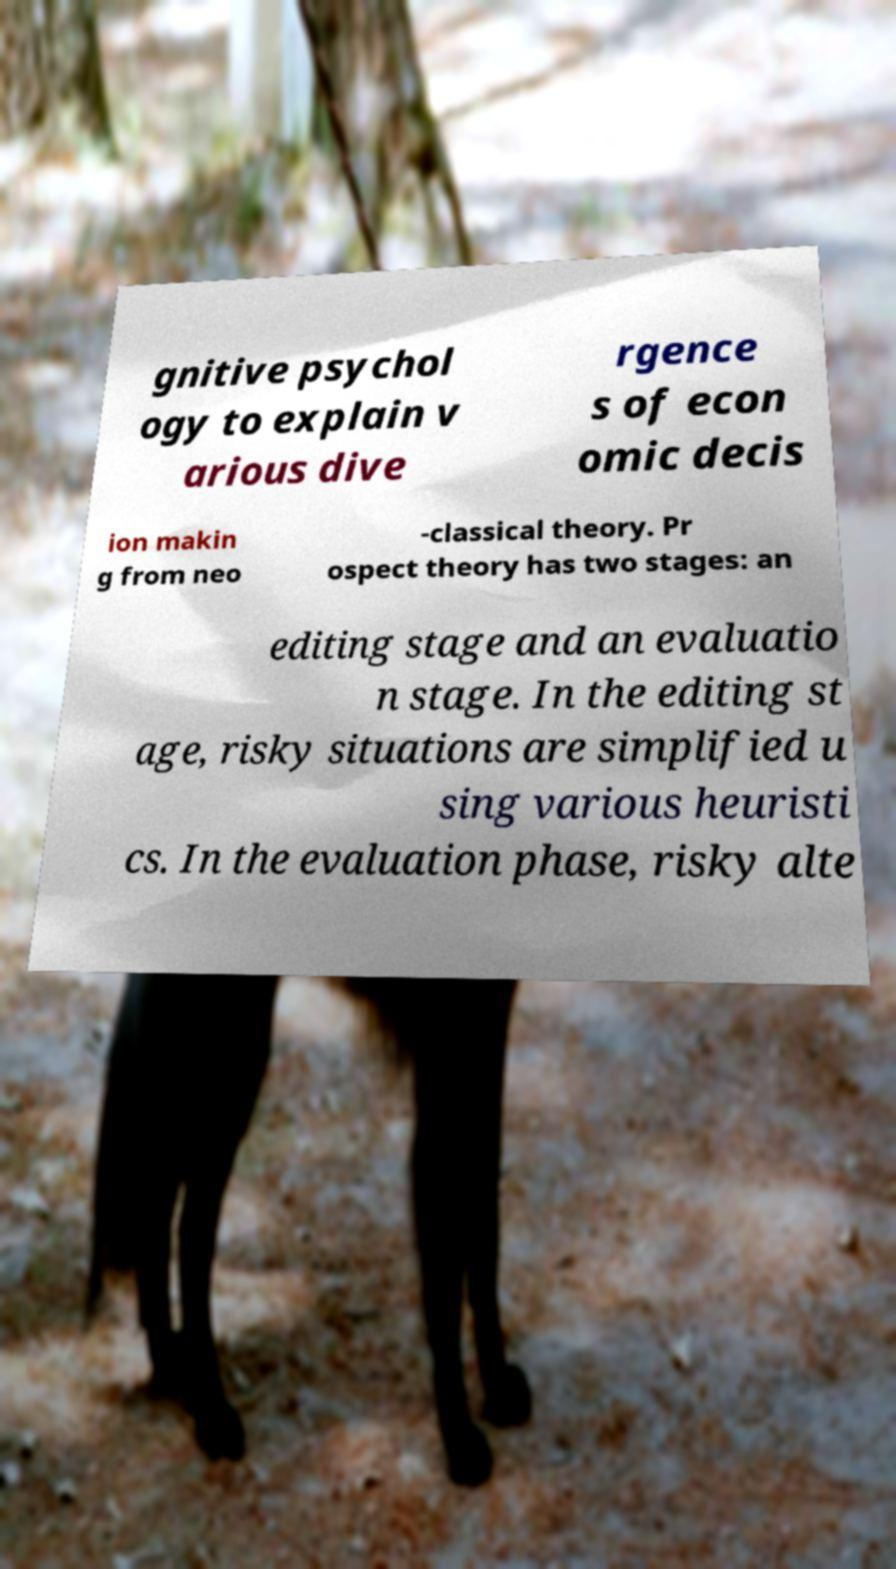Can you accurately transcribe the text from the provided image for me? gnitive psychol ogy to explain v arious dive rgence s of econ omic decis ion makin g from neo -classical theory. Pr ospect theory has two stages: an editing stage and an evaluatio n stage. In the editing st age, risky situations are simplified u sing various heuristi cs. In the evaluation phase, risky alte 